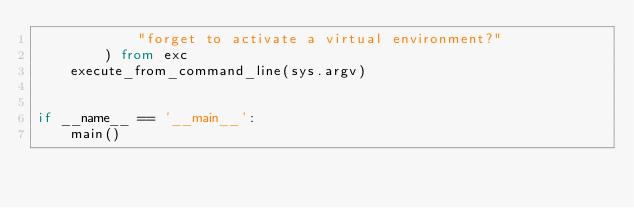Convert code to text. <code><loc_0><loc_0><loc_500><loc_500><_Python_>            "forget to activate a virtual environment?"
        ) from exc
    execute_from_command_line(sys.argv)


if __name__ == '__main__':
    main()
</code> 